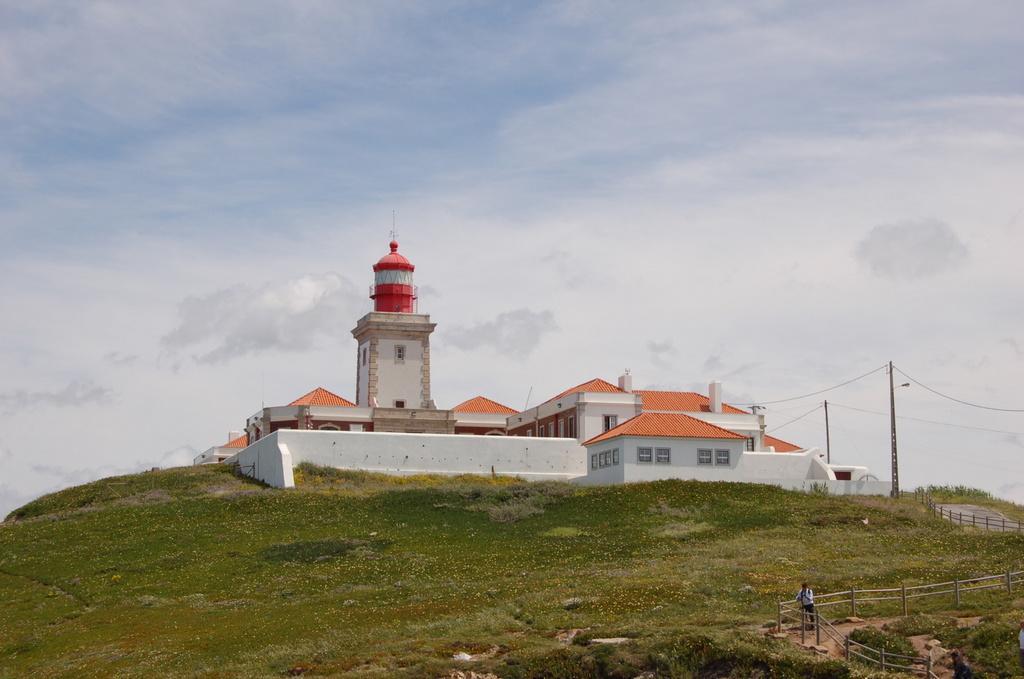In one or two sentences, can you explain what this image depicts? In this image, in the middle, we can see a building, glass window. On the right of the image, we can see a electric pole, electric wires, wood fence and a person standing on the land. At the top, we can see a sky which is cloudy, at the bottom, we can see a grass and few plants, we can also see some rocks. 